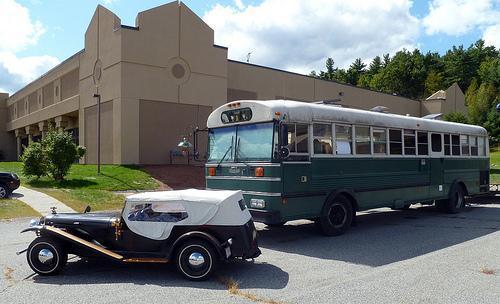How many vehicles are in the photo?
Give a very brief answer. 2. 